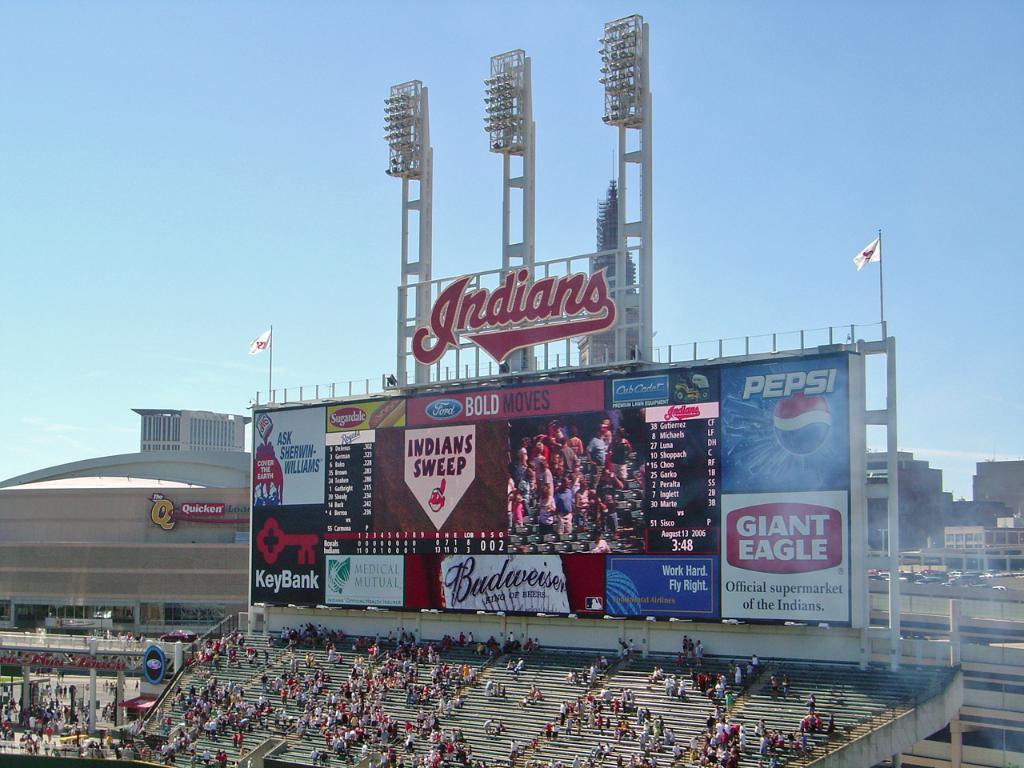<image>
Provide a brief description of the given image. A large billboard at a stadium displaying the words "Indian Sweep" on the screen. 